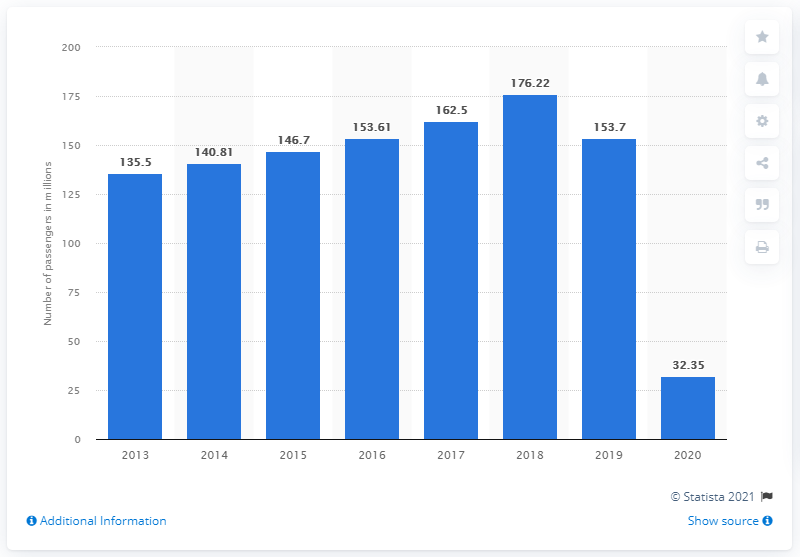Give some essential details in this illustration. In 2019, United Kingdom-based airlines lifted a total of 153,610 passengers. 